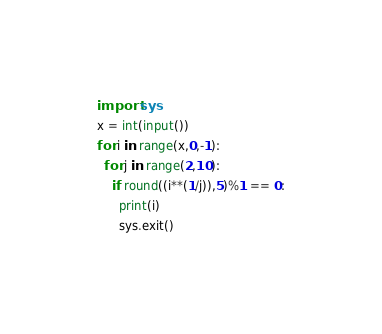<code> <loc_0><loc_0><loc_500><loc_500><_Python_>import sys
x = int(input())
for i in range(x,0,-1):
  for j in range(2,10):
    if round((i**(1/j)),5)%1 == 0:
      print(i)
      sys.exit()</code> 